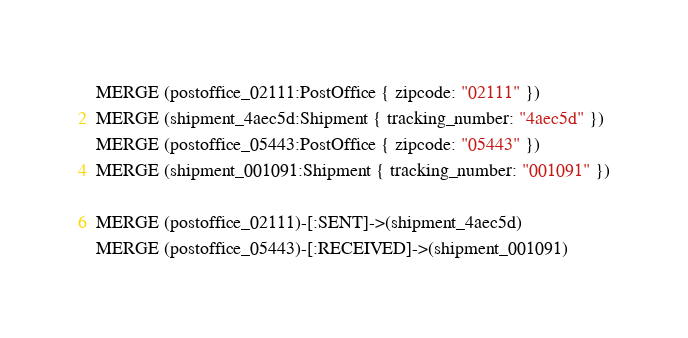Convert code to text. <code><loc_0><loc_0><loc_500><loc_500><_SQL_>MERGE (postoffice_02111:PostOffice { zipcode: "02111" })
MERGE (shipment_4aec5d:Shipment { tracking_number: "4aec5d" })
MERGE (postoffice_05443:PostOffice { zipcode: "05443" })
MERGE (shipment_001091:Shipment { tracking_number: "001091" })

MERGE (postoffice_02111)-[:SENT]->(shipment_4aec5d)
MERGE (postoffice_05443)-[:RECEIVED]->(shipment_001091)
</code> 